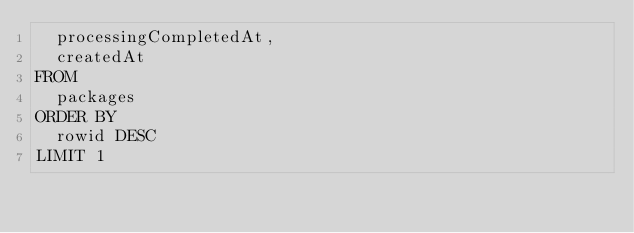<code> <loc_0><loc_0><loc_500><loc_500><_SQL_>  processingCompletedAt,
  createdAt
FROM
  packages
ORDER BY
  rowid DESC
LIMIT 1
</code> 